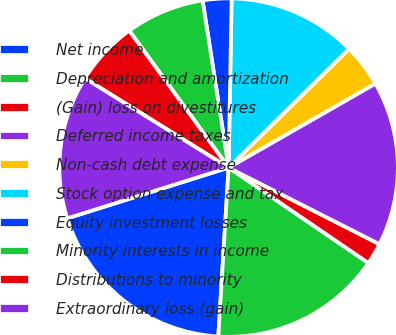Convert chart. <chart><loc_0><loc_0><loc_500><loc_500><pie_chart><fcel>Net income<fcel>Depreciation and amortization<fcel>(Gain) loss on divestitures<fcel>Deferred income taxes<fcel>Non-cash debt expense<fcel>Stock option expense and tax<fcel>Equity investment losses<fcel>Minority interests in income<fcel>Distributions to minority<fcel>Extraordinary loss (gain)<nl><fcel>19.18%<fcel>16.44%<fcel>2.06%<fcel>15.75%<fcel>4.11%<fcel>12.33%<fcel>2.74%<fcel>7.53%<fcel>6.16%<fcel>13.7%<nl></chart> 